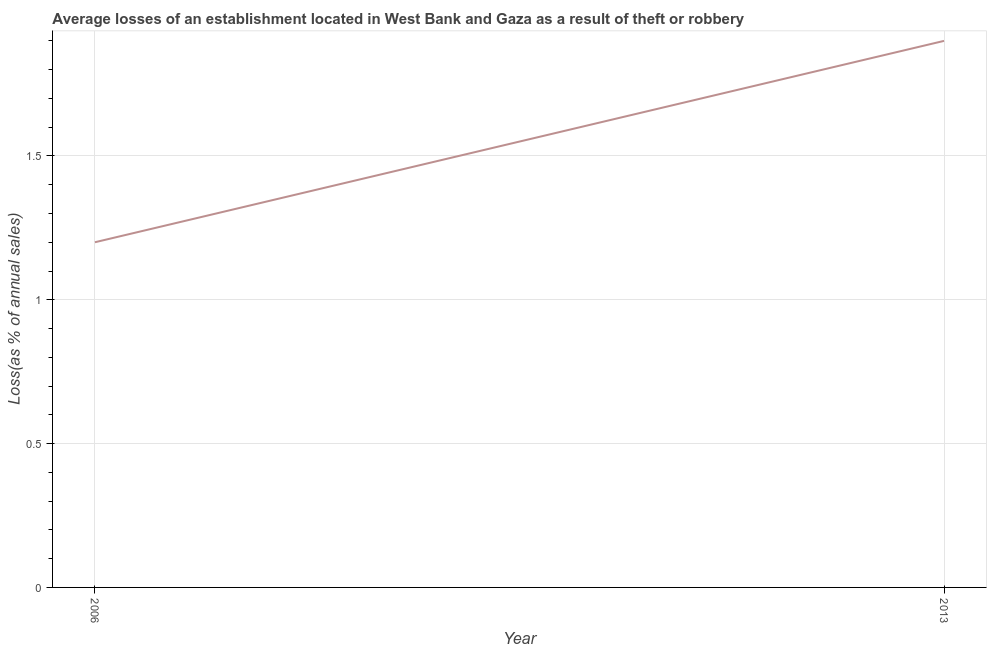Across all years, what is the minimum losses due to theft?
Your answer should be very brief. 1.2. What is the sum of the losses due to theft?
Your answer should be very brief. 3.1. What is the average losses due to theft per year?
Offer a very short reply. 1.55. What is the median losses due to theft?
Provide a short and direct response. 1.55. In how many years, is the losses due to theft greater than 0.8 %?
Give a very brief answer. 2. What is the ratio of the losses due to theft in 2006 to that in 2013?
Give a very brief answer. 0.63. What is the difference between two consecutive major ticks on the Y-axis?
Give a very brief answer. 0.5. What is the title of the graph?
Provide a short and direct response. Average losses of an establishment located in West Bank and Gaza as a result of theft or robbery. What is the label or title of the Y-axis?
Your answer should be compact. Loss(as % of annual sales). What is the Loss(as % of annual sales) of 2013?
Give a very brief answer. 1.9. What is the difference between the Loss(as % of annual sales) in 2006 and 2013?
Offer a very short reply. -0.7. What is the ratio of the Loss(as % of annual sales) in 2006 to that in 2013?
Keep it short and to the point. 0.63. 